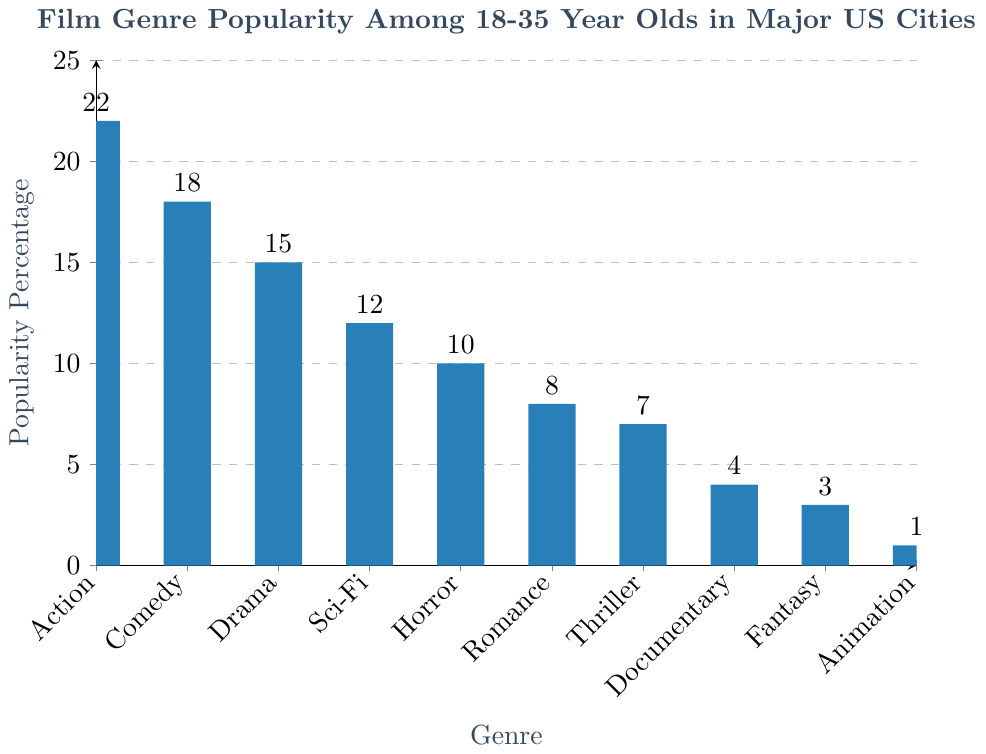What genre is the most popular among 18-35 year olds in major US cities? The bar representing the genre 'Action' is the tallest on the plot. This indicates that 'Action' has the highest popularity percentage.
Answer: Action How much more popular is Action than Science-Fiction? The popularity percentage of Action is 22%, and Sci-Fi is 12%. The difference is 22% - 12% = 10%.
Answer: 10% Which genre has the lowest popularity among 18-35 year olds in major US cities? The shortest bar represents Animation with a popularity percentage of 1%.
Answer: Animation What is the combined popularity percentage of Horror and Romance genres? Horror has a popularity percentage of 10%, and Romance has 8%. The combined value is 10% + 8% = 18%.
Answer: 18% Is Comedy more popular than Drama? The bar for Comedy is taller than the bar for Drama. Comedy has an 18% popularity percentage, whereas Drama has 15%.
Answer: Yes What is the difference in popularity between the most and least popular genres? The most popular genre is Action at 22% and the least popular is Animation at 1%. The difference is 22% - 1% = 21%.
Answer: 21% Are there any genres with popularity below 5%? The genres Documentary, Fantasy, and Animation have popularity percentages of 4%, 3%, and 1%, respectively.
Answer: Yes What percentage of respondents prefer Thriller over Documentary? Thriller has a popularity percentage of 7%, while Documentary has 4%. The difference is 7% - 4% = 3%.
Answer: 3% Does the combined popularity of Documentary, Fantasy, and Animation equal the popularity of Drama? Documentary, Fantasy, and Animation have percentages of 4%, 3%, and 1% respectively. Their combined popularity is 4% + 3% + 1% = 8%. Drama has a 15% popularity.
Answer: No How does the popularity of Action compare to the combined popularity of Romance and Thriller? Action has a popularity of 22%. Romance and Thriller combined have 8% + 7% = 15%. Action is more popular by 22% - 15% = 7%.
Answer: 7% 